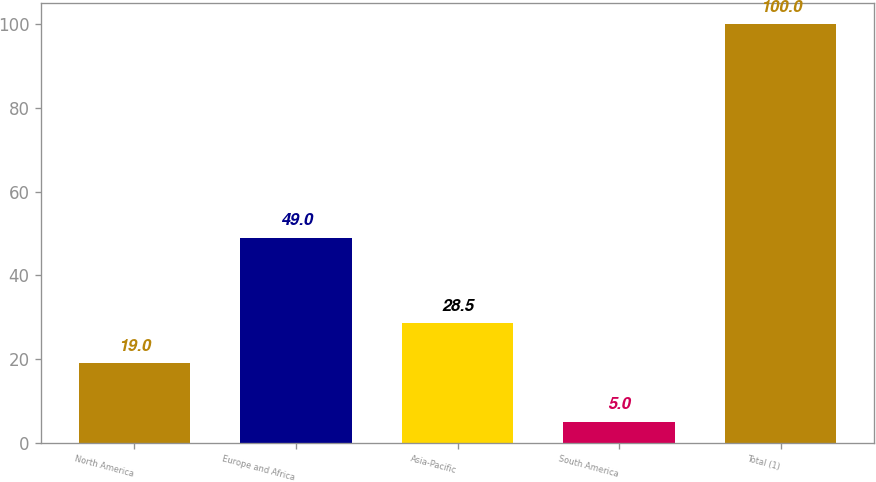Convert chart. <chart><loc_0><loc_0><loc_500><loc_500><bar_chart><fcel>North America<fcel>Europe and Africa<fcel>Asia-Pacific<fcel>South America<fcel>Total (1)<nl><fcel>19<fcel>49<fcel>28.5<fcel>5<fcel>100<nl></chart> 